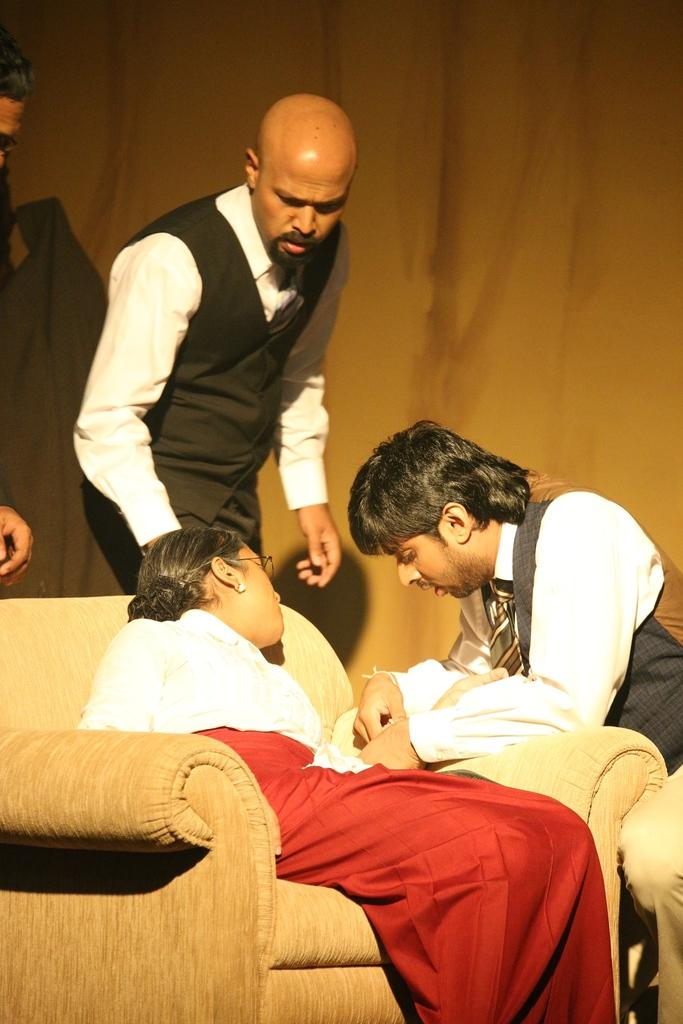What is the woman in the image doing? The woman is sitting on a chair in the image. Who is interacting with the woman in the image? There is a person holding the woman's hand in the image. How many people are standing in the image? There are two persons standing in the image. What type of transport is visible in the image? There is no transport visible in the image. What is the history of the woman sitting on the chair in the image? The image does not provide any information about the woman's history. 